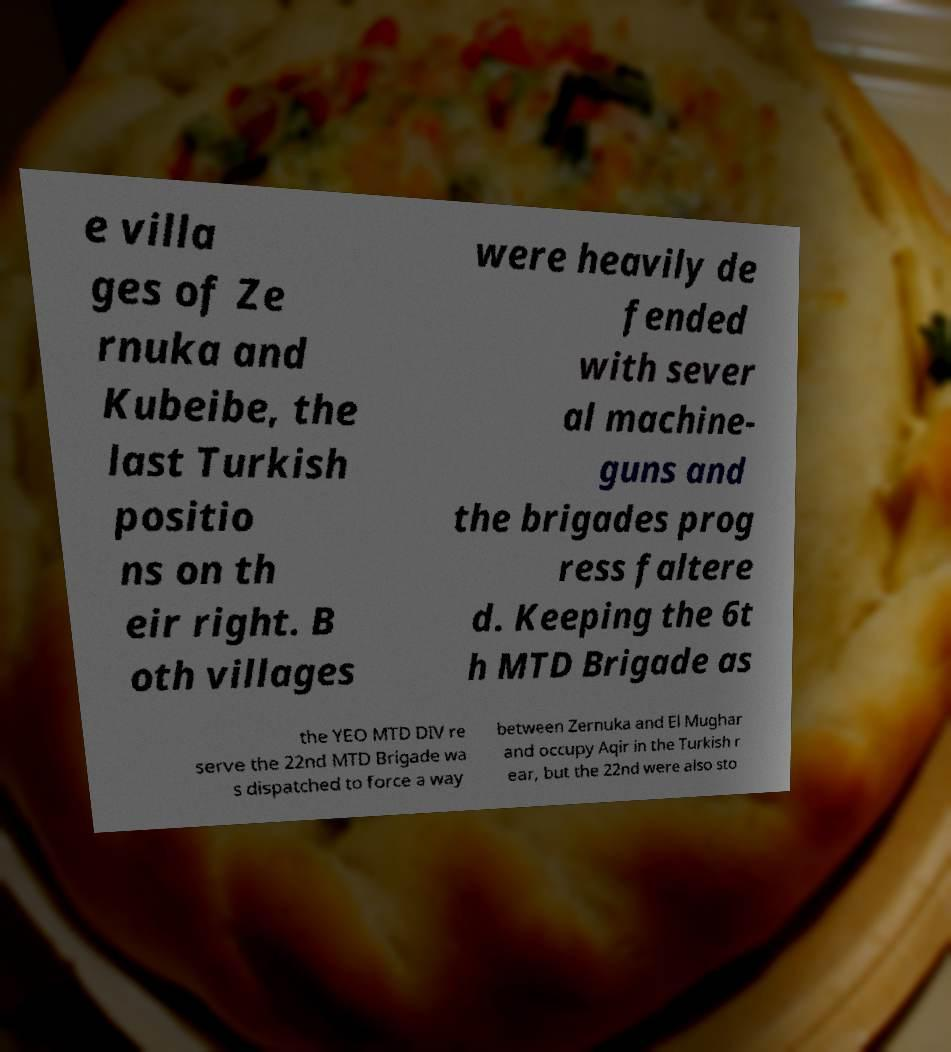Can you accurately transcribe the text from the provided image for me? e villa ges of Ze rnuka and Kubeibe, the last Turkish positio ns on th eir right. B oth villages were heavily de fended with sever al machine- guns and the brigades prog ress faltere d. Keeping the 6t h MTD Brigade as the YEO MTD DIV re serve the 22nd MTD Brigade wa s dispatched to force a way between Zernuka and El Mughar and occupy Aqir in the Turkish r ear, but the 22nd were also sto 